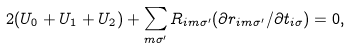Convert formula to latex. <formula><loc_0><loc_0><loc_500><loc_500>2 ( U _ { 0 } + U _ { 1 } + U _ { 2 } ) + \sum _ { m \sigma ^ { \prime } } R _ { i m \sigma ^ { \prime } } ( \partial r _ { i m \sigma ^ { \prime } } / \partial t _ { i \sigma } ) = 0 ,</formula> 